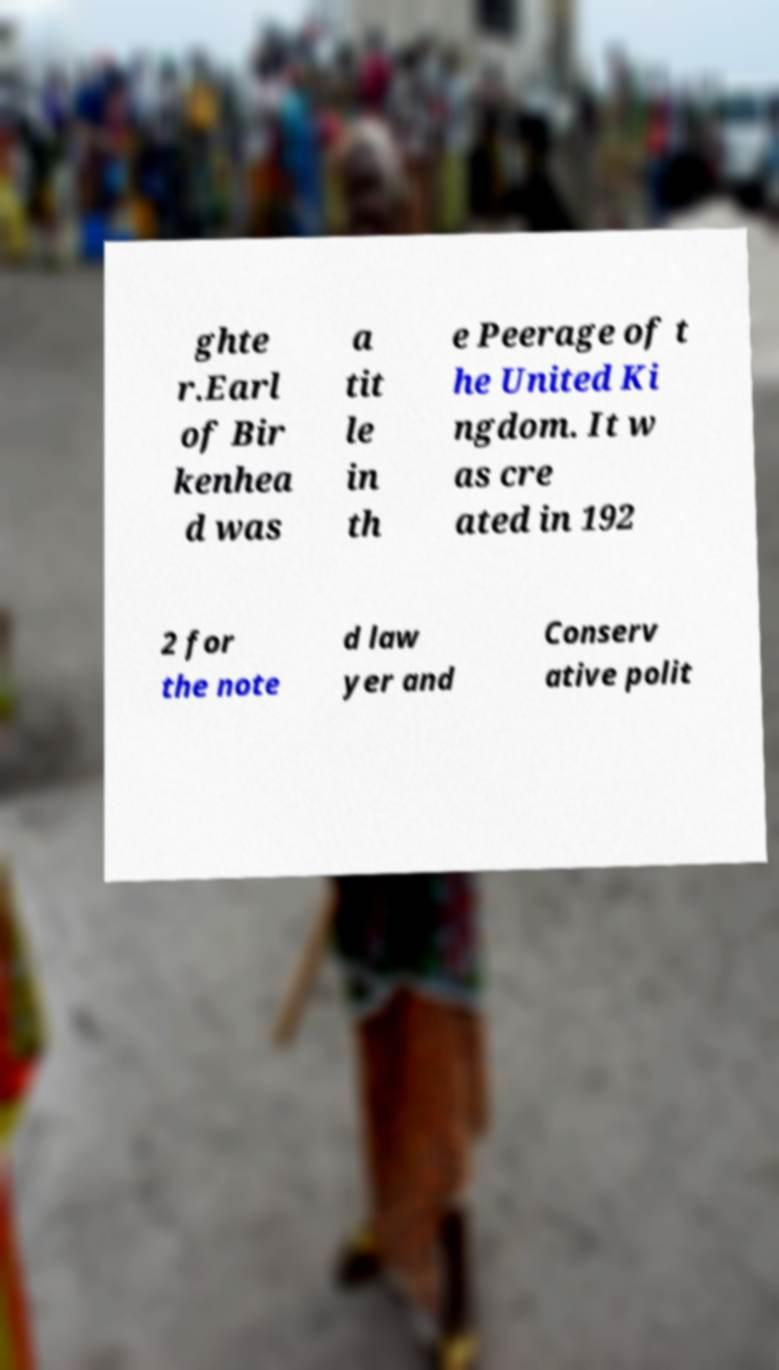Please read and relay the text visible in this image. What does it say? ghte r.Earl of Bir kenhea d was a tit le in th e Peerage of t he United Ki ngdom. It w as cre ated in 192 2 for the note d law yer and Conserv ative polit 